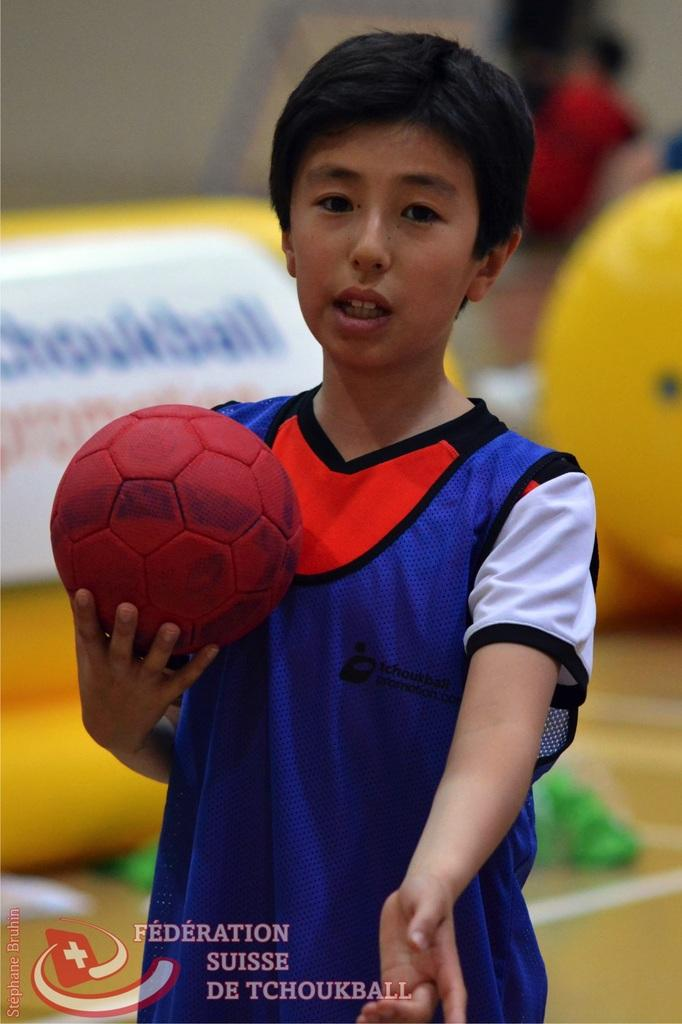Who is the main subject in the image? There is a boy in the image. What is the boy holding in his hand? The boy is holding a red ball in his hand. Can you describe the background of the image? The background of the image is blurry. Are there any other people visible in the image? Yes, there is a person visible in the background. What type of surface is shown in the image? The image shows a floor. What type of whip can be seen in the boy's hand in the image? There is no whip present in the image; the boy is holding a red ball in his hand. 